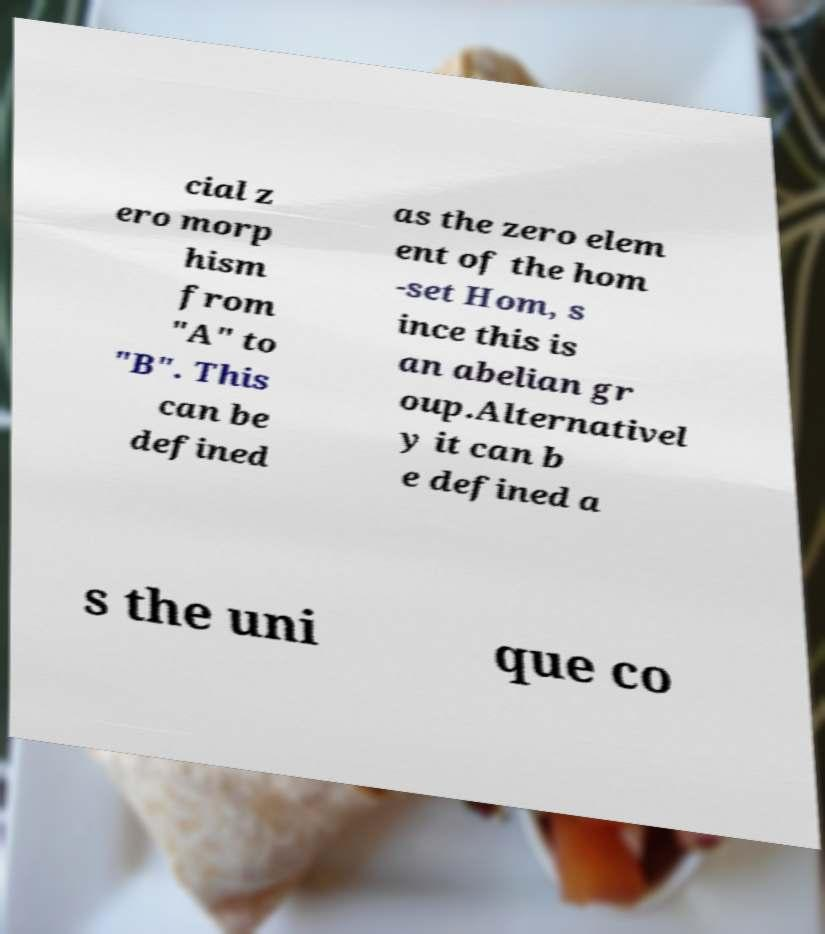There's text embedded in this image that I need extracted. Can you transcribe it verbatim? cial z ero morp hism from "A" to "B". This can be defined as the zero elem ent of the hom -set Hom, s ince this is an abelian gr oup.Alternativel y it can b e defined a s the uni que co 